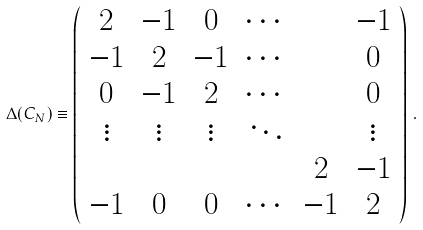<formula> <loc_0><loc_0><loc_500><loc_500>\Delta ( C _ { N } ) \equiv \left ( \begin{array} { c c c c c c } 2 & - 1 & 0 & \cdots & & - 1 \\ - 1 & 2 & - 1 & \cdots & & 0 \\ 0 & - 1 & 2 & \cdots & & 0 \\ \vdots & \vdots & \vdots & \ddots & & \vdots \\ & & & & 2 & - 1 \\ - 1 & 0 & 0 & \cdots & - 1 & 2 \end{array} \right ) \, .</formula> 